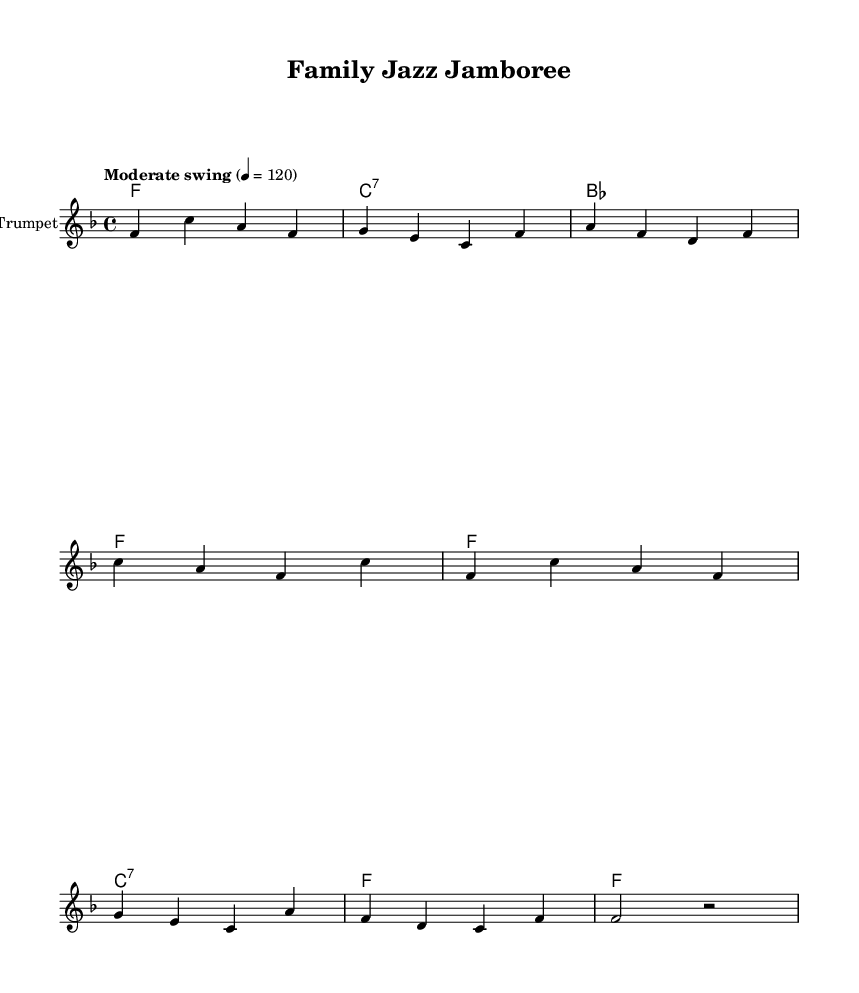What is the key signature of this music? The key signature shown in the music is F major, which includes one flat (B flat). This can be determined by looking at the key signature at the beginning of the staff.
Answer: F major What is the time signature of this music? The time signature indicated at the beginning of the music is 4/4, which means there are four beats in each measure and the quarter note gets one beat. This is usually found at the start of the score.
Answer: 4/4 What is the tempo marking for this piece? The tempo marking is "Moderate swing" and indicates the intended speed of the music. It specifies the swing feel, which is characteristic of jazz. This is indicated at the start of the score in the tempo section.
Answer: Moderate swing How many measures are there in the trumpet part? By counting the vertical lines (bar lines) in the trumpet's music section, we can see there are eight measures total. Each measure is separated by a vertical line, which indicates a new measure.
Answer: Eight What is the primary chord used in the piece? The primary chord used throughout the piece is F major, which is visually indicated in the chord names section. The chord most frequently repeated in the progression is F, appearing in multiple measures.
Answer: F major What is the style of music reflected in the lyrics? The lyrics reflect a fun and lively family-friendly atmosphere typical of New Orleans-style jazz, emphasizing dancing and enjoyment. The lyrics provide an inviting and engaging message relevant to family activities.
Answer: New Orleans-style jazz 